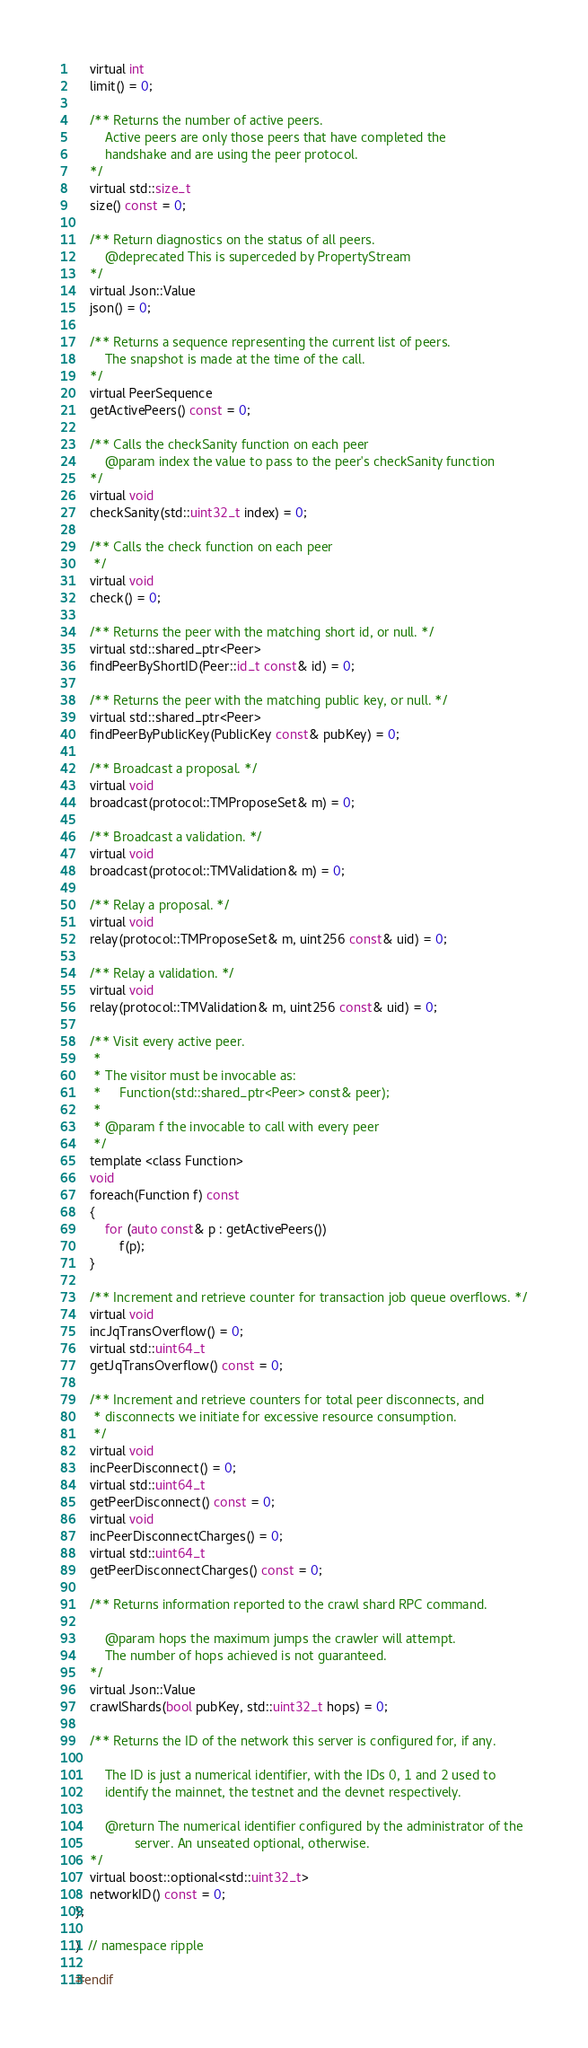<code> <loc_0><loc_0><loc_500><loc_500><_C_>    virtual int
    limit() = 0;

    /** Returns the number of active peers.
        Active peers are only those peers that have completed the
        handshake and are using the peer protocol.
    */
    virtual std::size_t
    size() const = 0;

    /** Return diagnostics on the status of all peers.
        @deprecated This is superceded by PropertyStream
    */
    virtual Json::Value
    json() = 0;

    /** Returns a sequence representing the current list of peers.
        The snapshot is made at the time of the call.
    */
    virtual PeerSequence
    getActivePeers() const = 0;

    /** Calls the checkSanity function on each peer
        @param index the value to pass to the peer's checkSanity function
    */
    virtual void
    checkSanity(std::uint32_t index) = 0;

    /** Calls the check function on each peer
     */
    virtual void
    check() = 0;

    /** Returns the peer with the matching short id, or null. */
    virtual std::shared_ptr<Peer>
    findPeerByShortID(Peer::id_t const& id) = 0;

    /** Returns the peer with the matching public key, or null. */
    virtual std::shared_ptr<Peer>
    findPeerByPublicKey(PublicKey const& pubKey) = 0;

    /** Broadcast a proposal. */
    virtual void
    broadcast(protocol::TMProposeSet& m) = 0;

    /** Broadcast a validation. */
    virtual void
    broadcast(protocol::TMValidation& m) = 0;

    /** Relay a proposal. */
    virtual void
    relay(protocol::TMProposeSet& m, uint256 const& uid) = 0;

    /** Relay a validation. */
    virtual void
    relay(protocol::TMValidation& m, uint256 const& uid) = 0;

    /** Visit every active peer.
     *
     * The visitor must be invocable as:
     *     Function(std::shared_ptr<Peer> const& peer);
     *
     * @param f the invocable to call with every peer
     */
    template <class Function>
    void
    foreach(Function f) const
    {
        for (auto const& p : getActivePeers())
            f(p);
    }

    /** Increment and retrieve counter for transaction job queue overflows. */
    virtual void
    incJqTransOverflow() = 0;
    virtual std::uint64_t
    getJqTransOverflow() const = 0;

    /** Increment and retrieve counters for total peer disconnects, and
     * disconnects we initiate for excessive resource consumption.
     */
    virtual void
    incPeerDisconnect() = 0;
    virtual std::uint64_t
    getPeerDisconnect() const = 0;
    virtual void
    incPeerDisconnectCharges() = 0;
    virtual std::uint64_t
    getPeerDisconnectCharges() const = 0;

    /** Returns information reported to the crawl shard RPC command.

        @param hops the maximum jumps the crawler will attempt.
        The number of hops achieved is not guaranteed.
    */
    virtual Json::Value
    crawlShards(bool pubKey, std::uint32_t hops) = 0;

    /** Returns the ID of the network this server is configured for, if any.

        The ID is just a numerical identifier, with the IDs 0, 1 and 2 used to
        identify the mainnet, the testnet and the devnet respectively.

        @return The numerical identifier configured by the administrator of the
                server. An unseated optional, otherwise.
    */
    virtual boost::optional<std::uint32_t>
    networkID() const = 0;
};

}  // namespace ripple

#endif
</code> 